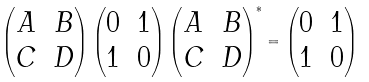Convert formula to latex. <formula><loc_0><loc_0><loc_500><loc_500>\begin{pmatrix} A & B \\ C & D \end{pmatrix} \begin{pmatrix} 0 & 1 \\ 1 & 0 \end{pmatrix} \begin{pmatrix} A & B \\ C & D \end{pmatrix} ^ { * } = \begin{pmatrix} 0 & 1 \\ 1 & 0 \end{pmatrix}</formula> 